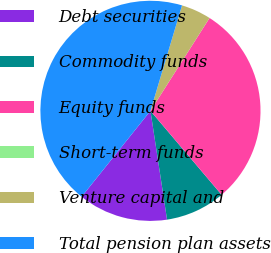Convert chart. <chart><loc_0><loc_0><loc_500><loc_500><pie_chart><fcel>Debt securities<fcel>Commodity funds<fcel>Equity funds<fcel>Short-term funds<fcel>Venture capital and<fcel>Total pension plan assets<nl><fcel>13.16%<fcel>8.78%<fcel>29.79%<fcel>0.0%<fcel>4.39%<fcel>43.88%<nl></chart> 